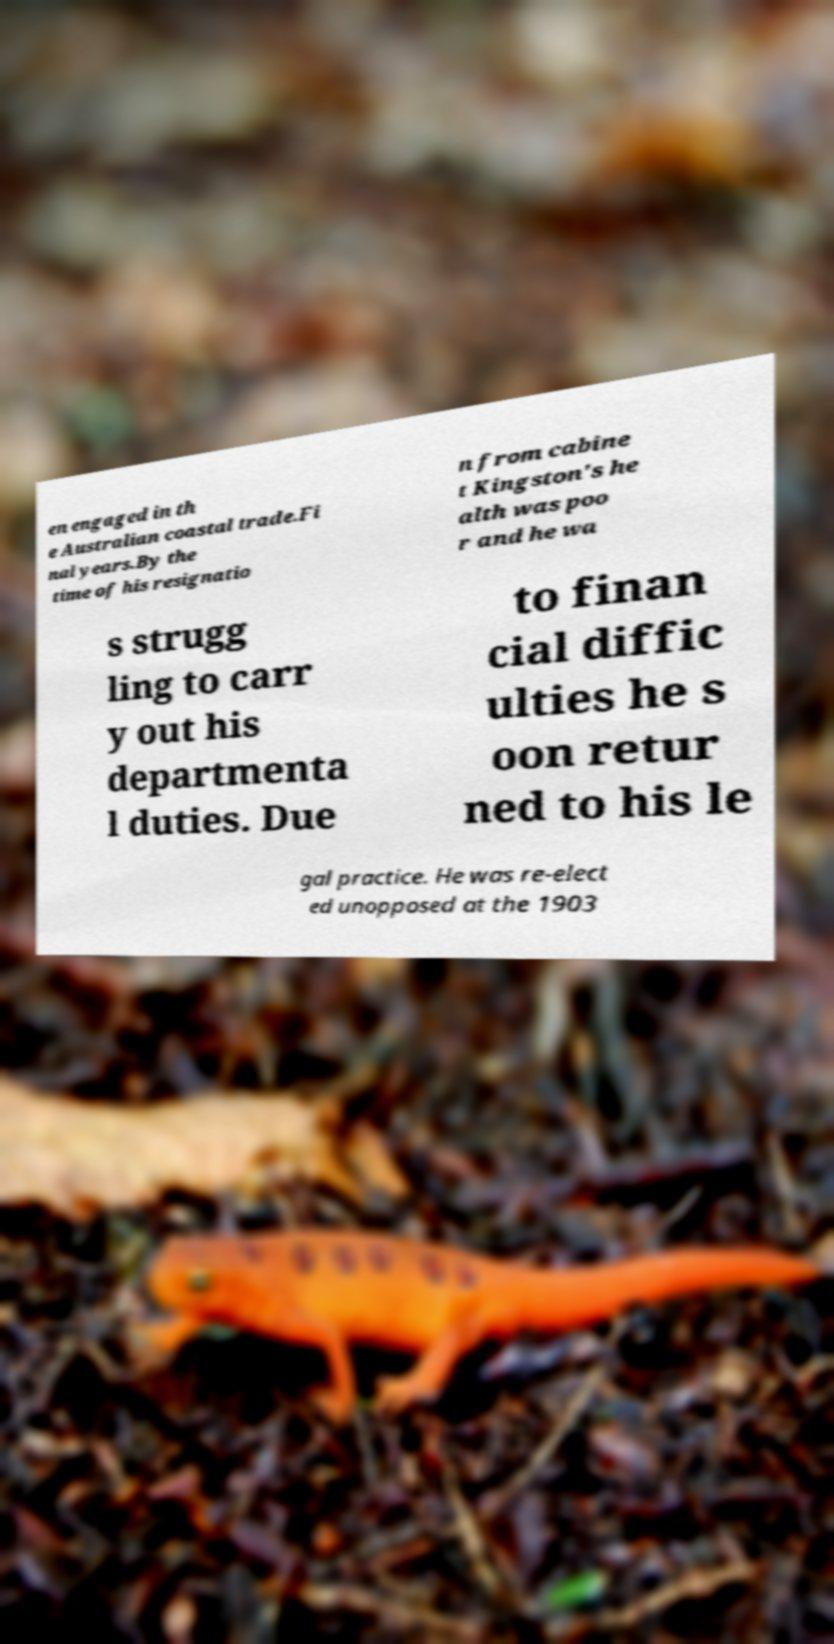Can you accurately transcribe the text from the provided image for me? en engaged in th e Australian coastal trade.Fi nal years.By the time of his resignatio n from cabine t Kingston's he alth was poo r and he wa s strugg ling to carr y out his departmenta l duties. Due to finan cial diffic ulties he s oon retur ned to his le gal practice. He was re-elect ed unopposed at the 1903 